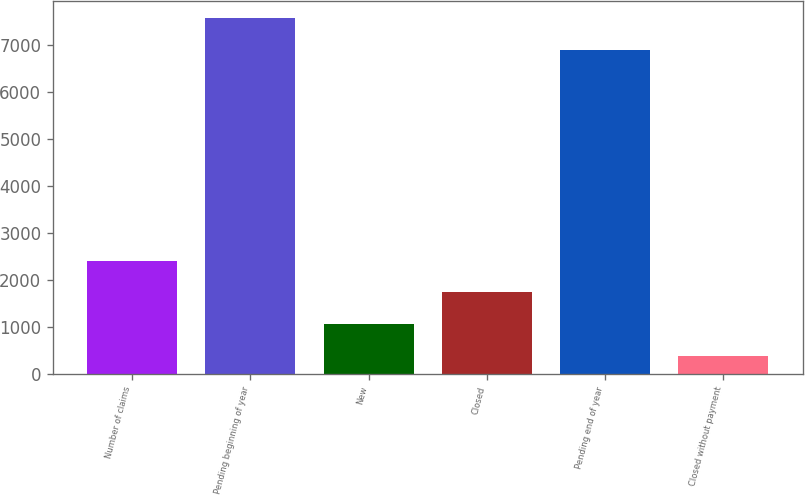Convert chart. <chart><loc_0><loc_0><loc_500><loc_500><bar_chart><fcel>Number of claims<fcel>Pending beginning of year<fcel>New<fcel>Closed<fcel>Pending end of year<fcel>Closed without payment<nl><fcel>2406.4<fcel>7560.8<fcel>1050.8<fcel>1728.6<fcel>6883<fcel>373<nl></chart> 